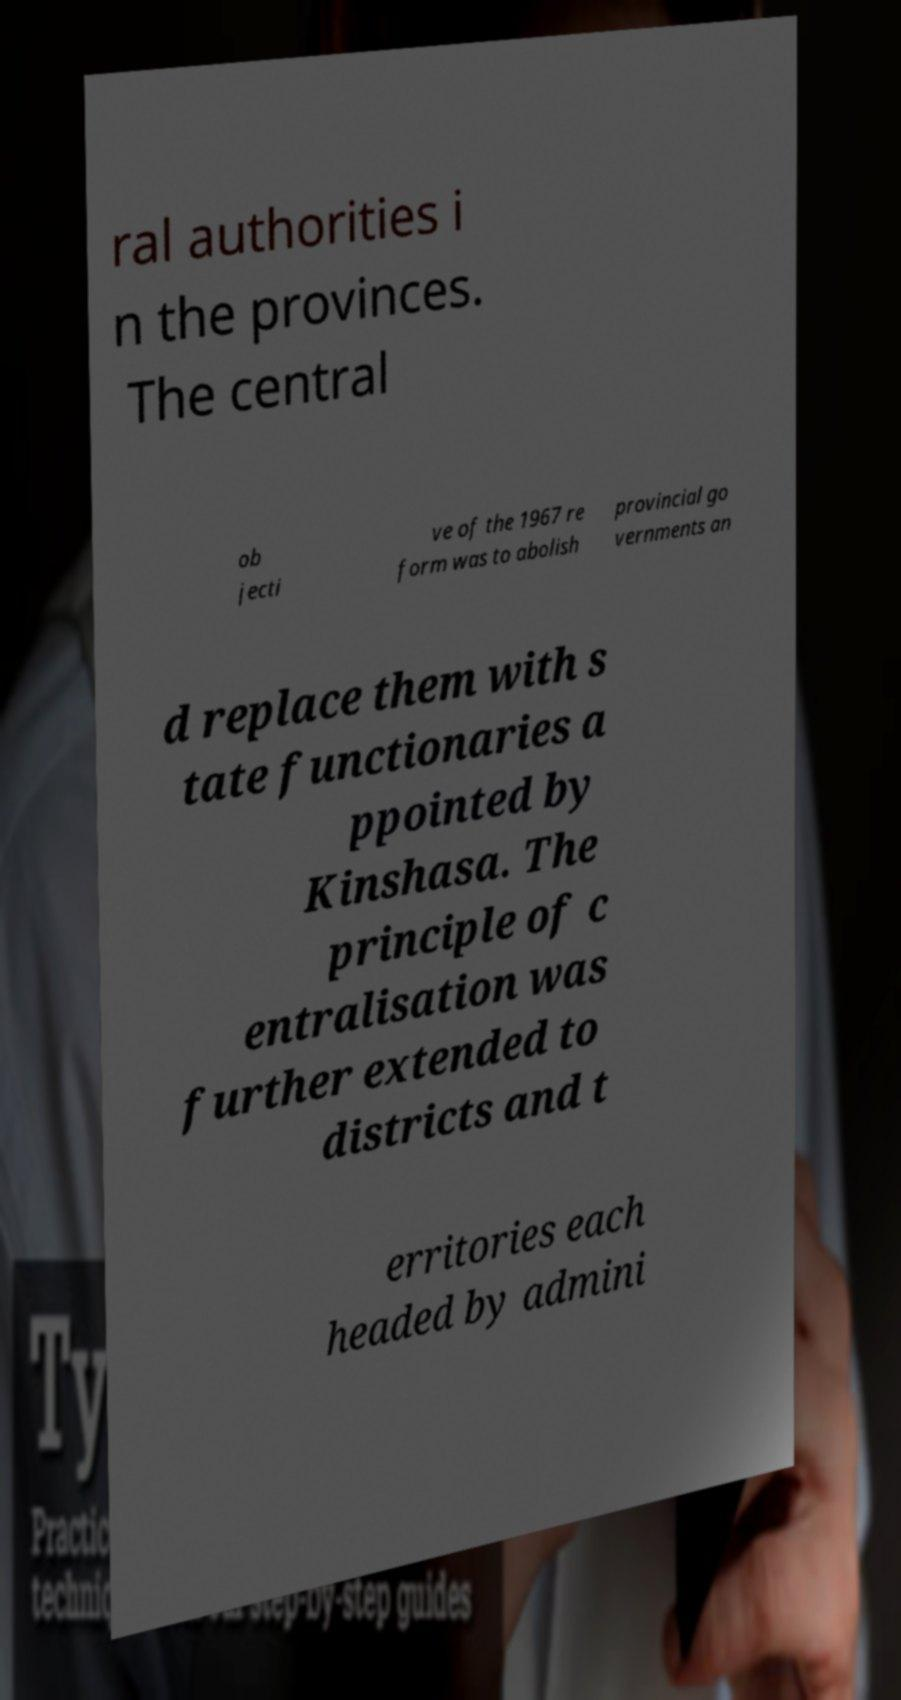Can you accurately transcribe the text from the provided image for me? ral authorities i n the provinces. The central ob jecti ve of the 1967 re form was to abolish provincial go vernments an d replace them with s tate functionaries a ppointed by Kinshasa. The principle of c entralisation was further extended to districts and t erritories each headed by admini 